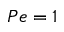Convert formula to latex. <formula><loc_0><loc_0><loc_500><loc_500>P e = 1</formula> 